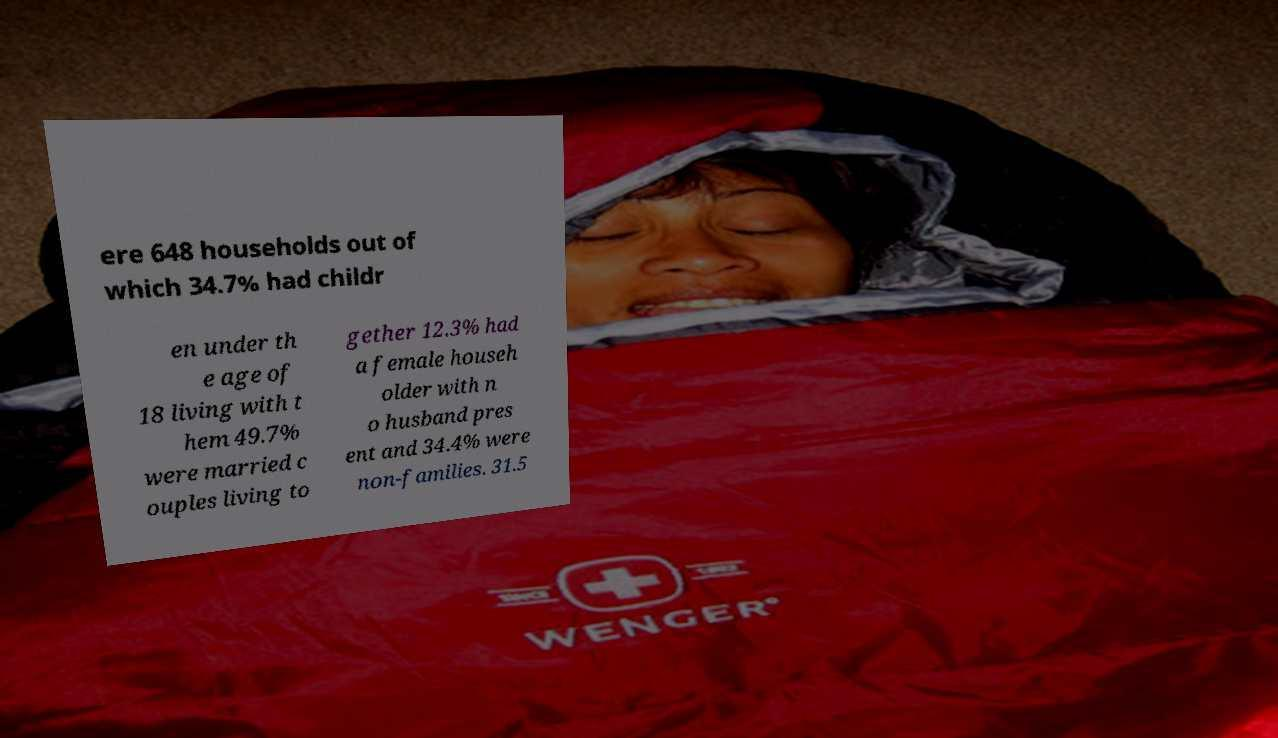There's text embedded in this image that I need extracted. Can you transcribe it verbatim? ere 648 households out of which 34.7% had childr en under th e age of 18 living with t hem 49.7% were married c ouples living to gether 12.3% had a female househ older with n o husband pres ent and 34.4% were non-families. 31.5 